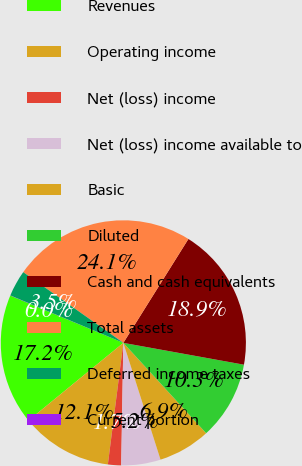Convert chart to OTSL. <chart><loc_0><loc_0><loc_500><loc_500><pie_chart><fcel>Revenues<fcel>Operating income<fcel>Net (loss) income<fcel>Net (loss) income available to<fcel>Basic<fcel>Diluted<fcel>Cash and cash equivalents<fcel>Total assets<fcel>Deferred income taxes<fcel>Current portion<nl><fcel>17.22%<fcel>12.06%<fcel>1.74%<fcel>5.18%<fcel>6.9%<fcel>10.34%<fcel>18.94%<fcel>24.11%<fcel>3.46%<fcel>0.02%<nl></chart> 